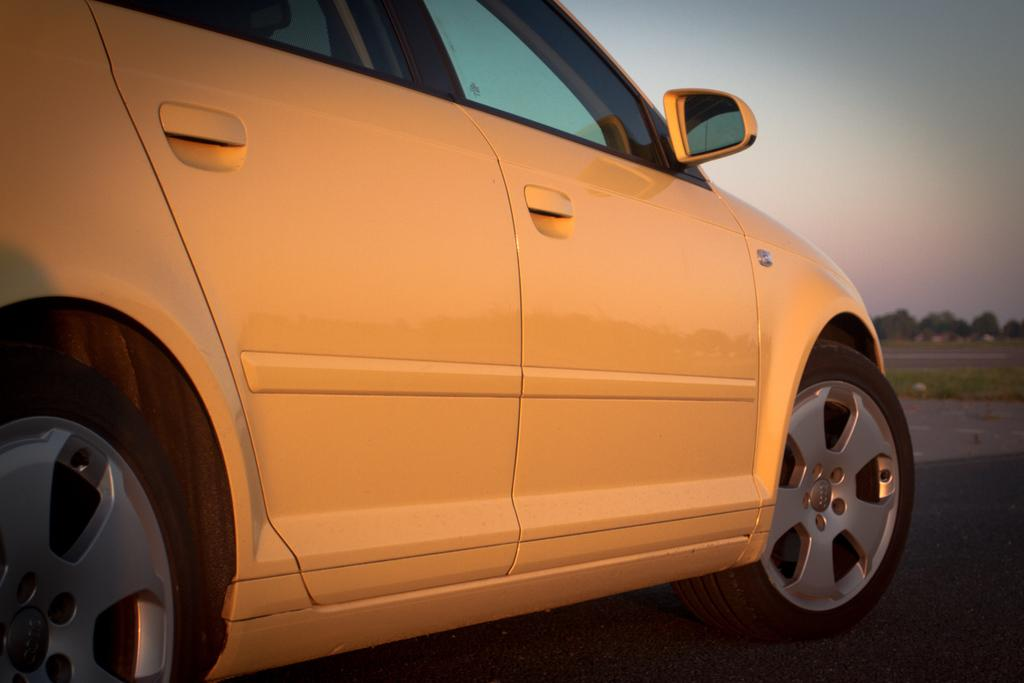What is the main subject of the picture? There is a car in the picture. What can be seen in the background of the picture? There are trees in the background of the picture. What color is the sky in the picture? The sky is blue in the picture. What type of canvas is being used to paint the volcano in the image? There is no canvas or volcano present in the image; it features a car and a blue sky. 